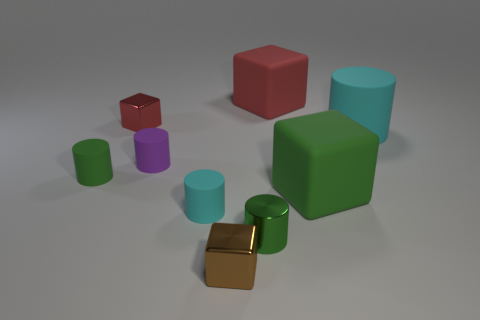Subtract all green rubber cylinders. How many cylinders are left? 4 Subtract 4 cubes. How many cubes are left? 0 Subtract all purple cylinders. How many cylinders are left? 4 Subtract all gray cubes. Subtract all gray balls. How many cubes are left? 4 Subtract all green cubes. How many green cylinders are left? 2 Subtract 0 yellow cubes. How many objects are left? 9 Subtract all cubes. How many objects are left? 5 Subtract all red shiny objects. Subtract all cyan things. How many objects are left? 6 Add 6 tiny cylinders. How many tiny cylinders are left? 10 Add 1 tiny rubber cubes. How many tiny rubber cubes exist? 1 